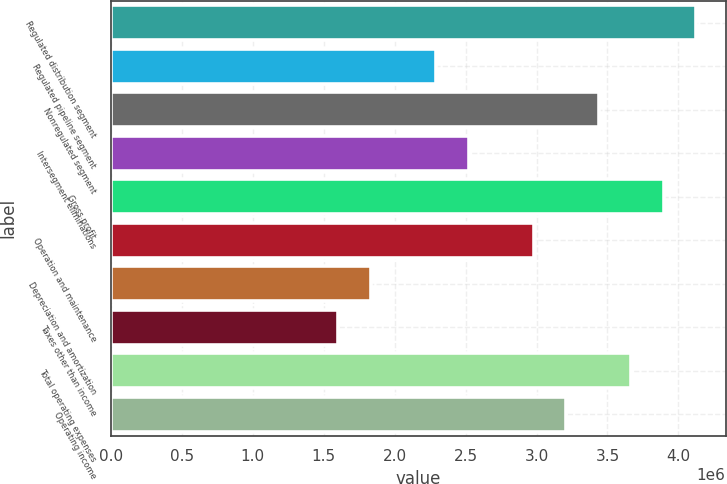Convert chart to OTSL. <chart><loc_0><loc_0><loc_500><loc_500><bar_chart><fcel>Regulated distribution segment<fcel>Regulated pipeline segment<fcel>Nonregulated segment<fcel>Intersegment eliminations<fcel>Gross profit<fcel>Operation and maintenance<fcel>Depreciation and amortization<fcel>Taxes other than income<fcel>Total operating expenses<fcel>Operating income<nl><fcel>4.12536e+06<fcel>2.29187e+06<fcel>3.4378e+06<fcel>2.52105e+06<fcel>3.89617e+06<fcel>2.97942e+06<fcel>1.83349e+06<fcel>1.60431e+06<fcel>3.66698e+06<fcel>3.20861e+06<nl></chart> 